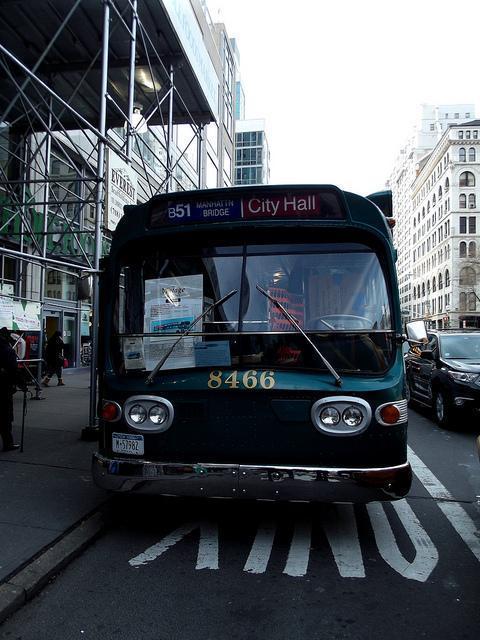How many cars are there?
Give a very brief answer. 1. 